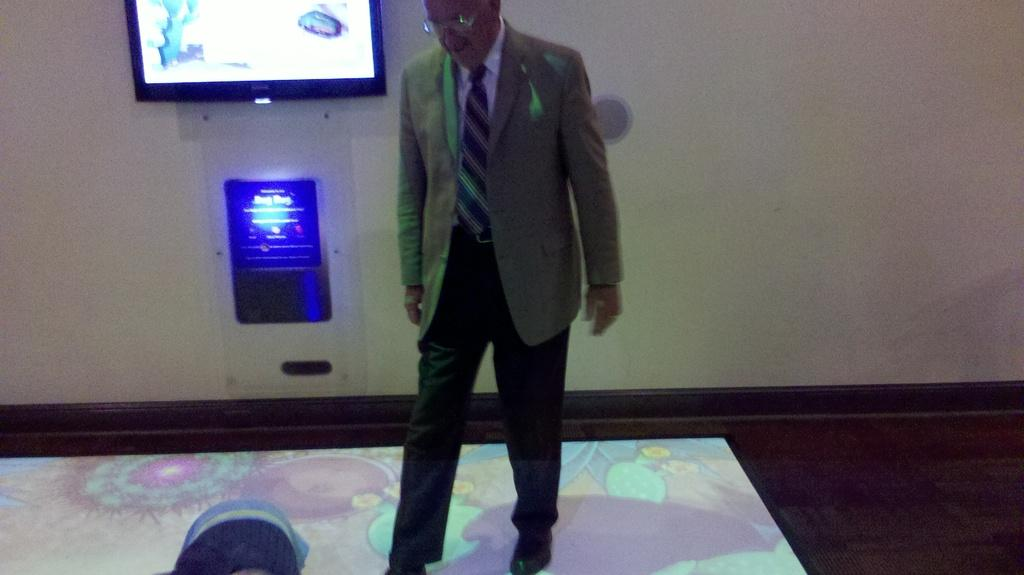What is the main subject of the image? There is a person in the image. Can you describe the person's attire? The person is wearing a coat, a tie, and glasses (specs). What can be seen in the background of the image? There is a wall in the background of the image, which has a screen and a device with blue color light on it. How many geese are flying over the person in the image? There are no geese visible in the image. 